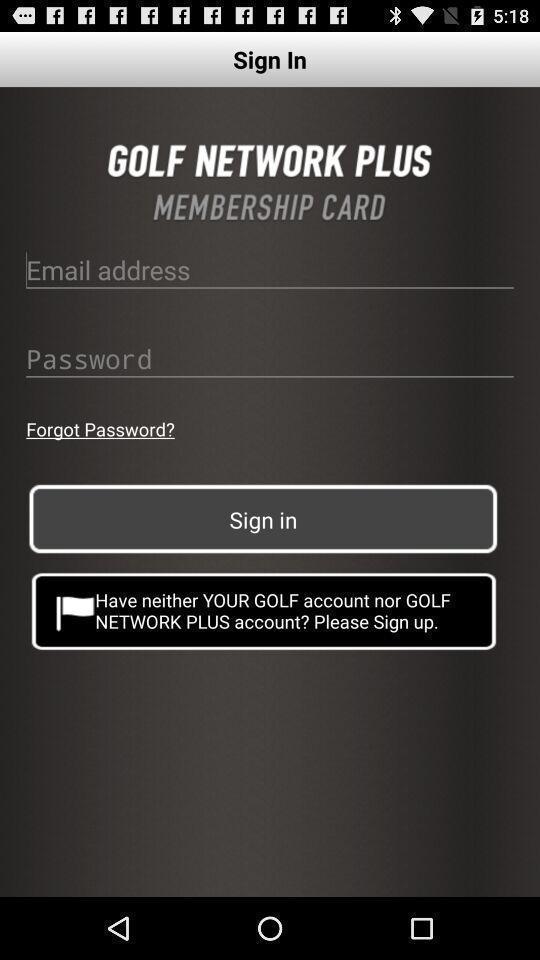Provide a textual representation of this image. Welcome to the sign in page. 